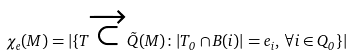Convert formula to latex. <formula><loc_0><loc_0><loc_500><loc_500>\chi _ { e } ( M ) = | \{ T \overrightarrow { \subset } \tilde { Q } ( M ) \colon | T _ { 0 } \cap B ( i ) | = e _ { i } , \, \forall i \in Q _ { 0 } \} |</formula> 